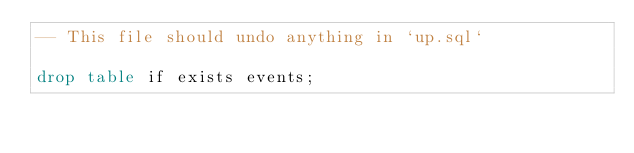<code> <loc_0><loc_0><loc_500><loc_500><_SQL_>-- This file should undo anything in `up.sql`

drop table if exists events;
</code> 